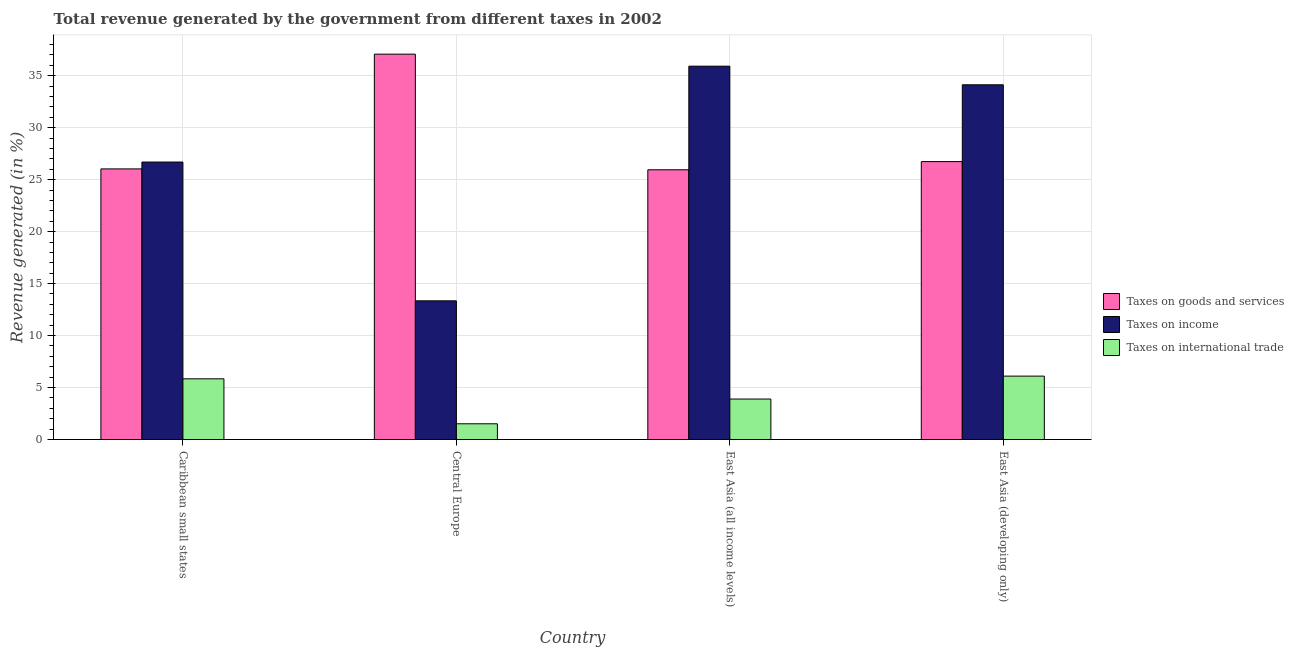How many different coloured bars are there?
Keep it short and to the point. 3. How many groups of bars are there?
Offer a terse response. 4. Are the number of bars on each tick of the X-axis equal?
Your answer should be compact. Yes. What is the label of the 2nd group of bars from the left?
Offer a very short reply. Central Europe. What is the percentage of revenue generated by tax on international trade in Central Europe?
Give a very brief answer. 1.51. Across all countries, what is the maximum percentage of revenue generated by taxes on income?
Keep it short and to the point. 35.92. Across all countries, what is the minimum percentage of revenue generated by tax on international trade?
Your answer should be compact. 1.51. In which country was the percentage of revenue generated by taxes on income maximum?
Keep it short and to the point. East Asia (all income levels). In which country was the percentage of revenue generated by taxes on goods and services minimum?
Provide a succinct answer. East Asia (all income levels). What is the total percentage of revenue generated by taxes on income in the graph?
Your answer should be very brief. 110.08. What is the difference between the percentage of revenue generated by tax on international trade in East Asia (all income levels) and that in East Asia (developing only)?
Offer a terse response. -2.2. What is the difference between the percentage of revenue generated by taxes on income in East Asia (developing only) and the percentage of revenue generated by taxes on goods and services in Caribbean small states?
Provide a short and direct response. 8.09. What is the average percentage of revenue generated by taxes on goods and services per country?
Provide a short and direct response. 28.95. What is the difference between the percentage of revenue generated by taxes on income and percentage of revenue generated by taxes on goods and services in East Asia (all income levels)?
Make the answer very short. 9.97. What is the ratio of the percentage of revenue generated by taxes on goods and services in East Asia (all income levels) to that in East Asia (developing only)?
Keep it short and to the point. 0.97. Is the difference between the percentage of revenue generated by taxes on goods and services in East Asia (all income levels) and East Asia (developing only) greater than the difference between the percentage of revenue generated by tax on international trade in East Asia (all income levels) and East Asia (developing only)?
Give a very brief answer. Yes. What is the difference between the highest and the second highest percentage of revenue generated by taxes on goods and services?
Offer a very short reply. 10.34. What is the difference between the highest and the lowest percentage of revenue generated by tax on international trade?
Give a very brief answer. 4.59. In how many countries, is the percentage of revenue generated by taxes on goods and services greater than the average percentage of revenue generated by taxes on goods and services taken over all countries?
Offer a terse response. 1. Is the sum of the percentage of revenue generated by tax on international trade in Caribbean small states and Central Europe greater than the maximum percentage of revenue generated by taxes on income across all countries?
Your response must be concise. No. What does the 1st bar from the left in Central Europe represents?
Offer a terse response. Taxes on goods and services. What does the 3rd bar from the right in Central Europe represents?
Your response must be concise. Taxes on goods and services. Are all the bars in the graph horizontal?
Keep it short and to the point. No. How many countries are there in the graph?
Give a very brief answer. 4. Does the graph contain any zero values?
Give a very brief answer. No. What is the title of the graph?
Give a very brief answer. Total revenue generated by the government from different taxes in 2002. What is the label or title of the X-axis?
Your answer should be compact. Country. What is the label or title of the Y-axis?
Make the answer very short. Revenue generated (in %). What is the Revenue generated (in %) in Taxes on goods and services in Caribbean small states?
Offer a very short reply. 26.04. What is the Revenue generated (in %) in Taxes on income in Caribbean small states?
Make the answer very short. 26.7. What is the Revenue generated (in %) of Taxes on international trade in Caribbean small states?
Provide a succinct answer. 5.84. What is the Revenue generated (in %) of Taxes on goods and services in Central Europe?
Provide a succinct answer. 37.08. What is the Revenue generated (in %) in Taxes on income in Central Europe?
Keep it short and to the point. 13.34. What is the Revenue generated (in %) in Taxes on international trade in Central Europe?
Offer a very short reply. 1.51. What is the Revenue generated (in %) in Taxes on goods and services in East Asia (all income levels)?
Offer a very short reply. 25.95. What is the Revenue generated (in %) of Taxes on income in East Asia (all income levels)?
Offer a terse response. 35.92. What is the Revenue generated (in %) in Taxes on international trade in East Asia (all income levels)?
Offer a terse response. 3.89. What is the Revenue generated (in %) in Taxes on goods and services in East Asia (developing only)?
Provide a succinct answer. 26.74. What is the Revenue generated (in %) of Taxes on income in East Asia (developing only)?
Give a very brief answer. 34.13. What is the Revenue generated (in %) of Taxes on international trade in East Asia (developing only)?
Provide a short and direct response. 6.1. Across all countries, what is the maximum Revenue generated (in %) in Taxes on goods and services?
Give a very brief answer. 37.08. Across all countries, what is the maximum Revenue generated (in %) of Taxes on income?
Keep it short and to the point. 35.92. Across all countries, what is the maximum Revenue generated (in %) of Taxes on international trade?
Provide a short and direct response. 6.1. Across all countries, what is the minimum Revenue generated (in %) in Taxes on goods and services?
Offer a very short reply. 25.95. Across all countries, what is the minimum Revenue generated (in %) of Taxes on income?
Give a very brief answer. 13.34. Across all countries, what is the minimum Revenue generated (in %) in Taxes on international trade?
Give a very brief answer. 1.51. What is the total Revenue generated (in %) of Taxes on goods and services in the graph?
Keep it short and to the point. 115.8. What is the total Revenue generated (in %) in Taxes on income in the graph?
Provide a short and direct response. 110.08. What is the total Revenue generated (in %) in Taxes on international trade in the graph?
Keep it short and to the point. 17.35. What is the difference between the Revenue generated (in %) in Taxes on goods and services in Caribbean small states and that in Central Europe?
Provide a succinct answer. -11.04. What is the difference between the Revenue generated (in %) in Taxes on income in Caribbean small states and that in Central Europe?
Your answer should be very brief. 13.35. What is the difference between the Revenue generated (in %) of Taxes on international trade in Caribbean small states and that in Central Europe?
Make the answer very short. 4.33. What is the difference between the Revenue generated (in %) of Taxes on goods and services in Caribbean small states and that in East Asia (all income levels)?
Give a very brief answer. 0.09. What is the difference between the Revenue generated (in %) of Taxes on income in Caribbean small states and that in East Asia (all income levels)?
Your answer should be very brief. -9.22. What is the difference between the Revenue generated (in %) of Taxes on international trade in Caribbean small states and that in East Asia (all income levels)?
Your answer should be very brief. 1.94. What is the difference between the Revenue generated (in %) of Taxes on goods and services in Caribbean small states and that in East Asia (developing only)?
Your answer should be compact. -0.7. What is the difference between the Revenue generated (in %) of Taxes on income in Caribbean small states and that in East Asia (developing only)?
Provide a succinct answer. -7.43. What is the difference between the Revenue generated (in %) in Taxes on international trade in Caribbean small states and that in East Asia (developing only)?
Make the answer very short. -0.26. What is the difference between the Revenue generated (in %) of Taxes on goods and services in Central Europe and that in East Asia (all income levels)?
Give a very brief answer. 11.13. What is the difference between the Revenue generated (in %) of Taxes on income in Central Europe and that in East Asia (all income levels)?
Make the answer very short. -22.58. What is the difference between the Revenue generated (in %) of Taxes on international trade in Central Europe and that in East Asia (all income levels)?
Offer a terse response. -2.38. What is the difference between the Revenue generated (in %) of Taxes on goods and services in Central Europe and that in East Asia (developing only)?
Offer a very short reply. 10.34. What is the difference between the Revenue generated (in %) in Taxes on income in Central Europe and that in East Asia (developing only)?
Make the answer very short. -20.78. What is the difference between the Revenue generated (in %) in Taxes on international trade in Central Europe and that in East Asia (developing only)?
Make the answer very short. -4.59. What is the difference between the Revenue generated (in %) of Taxes on goods and services in East Asia (all income levels) and that in East Asia (developing only)?
Your answer should be compact. -0.79. What is the difference between the Revenue generated (in %) of Taxes on income in East Asia (all income levels) and that in East Asia (developing only)?
Give a very brief answer. 1.79. What is the difference between the Revenue generated (in %) in Taxes on international trade in East Asia (all income levels) and that in East Asia (developing only)?
Make the answer very short. -2.2. What is the difference between the Revenue generated (in %) of Taxes on goods and services in Caribbean small states and the Revenue generated (in %) of Taxes on income in Central Europe?
Provide a short and direct response. 12.69. What is the difference between the Revenue generated (in %) in Taxes on goods and services in Caribbean small states and the Revenue generated (in %) in Taxes on international trade in Central Europe?
Ensure brevity in your answer.  24.52. What is the difference between the Revenue generated (in %) of Taxes on income in Caribbean small states and the Revenue generated (in %) of Taxes on international trade in Central Europe?
Keep it short and to the point. 25.18. What is the difference between the Revenue generated (in %) of Taxes on goods and services in Caribbean small states and the Revenue generated (in %) of Taxes on income in East Asia (all income levels)?
Your response must be concise. -9.88. What is the difference between the Revenue generated (in %) of Taxes on goods and services in Caribbean small states and the Revenue generated (in %) of Taxes on international trade in East Asia (all income levels)?
Give a very brief answer. 22.14. What is the difference between the Revenue generated (in %) of Taxes on income in Caribbean small states and the Revenue generated (in %) of Taxes on international trade in East Asia (all income levels)?
Provide a succinct answer. 22.8. What is the difference between the Revenue generated (in %) in Taxes on goods and services in Caribbean small states and the Revenue generated (in %) in Taxes on income in East Asia (developing only)?
Make the answer very short. -8.09. What is the difference between the Revenue generated (in %) in Taxes on goods and services in Caribbean small states and the Revenue generated (in %) in Taxes on international trade in East Asia (developing only)?
Your response must be concise. 19.94. What is the difference between the Revenue generated (in %) in Taxes on income in Caribbean small states and the Revenue generated (in %) in Taxes on international trade in East Asia (developing only)?
Make the answer very short. 20.6. What is the difference between the Revenue generated (in %) in Taxes on goods and services in Central Europe and the Revenue generated (in %) in Taxes on income in East Asia (all income levels)?
Provide a succinct answer. 1.16. What is the difference between the Revenue generated (in %) in Taxes on goods and services in Central Europe and the Revenue generated (in %) in Taxes on international trade in East Asia (all income levels)?
Make the answer very short. 33.18. What is the difference between the Revenue generated (in %) in Taxes on income in Central Europe and the Revenue generated (in %) in Taxes on international trade in East Asia (all income levels)?
Make the answer very short. 9.45. What is the difference between the Revenue generated (in %) in Taxes on goods and services in Central Europe and the Revenue generated (in %) in Taxes on income in East Asia (developing only)?
Offer a terse response. 2.95. What is the difference between the Revenue generated (in %) in Taxes on goods and services in Central Europe and the Revenue generated (in %) in Taxes on international trade in East Asia (developing only)?
Give a very brief answer. 30.98. What is the difference between the Revenue generated (in %) of Taxes on income in Central Europe and the Revenue generated (in %) of Taxes on international trade in East Asia (developing only)?
Your answer should be very brief. 7.24. What is the difference between the Revenue generated (in %) of Taxes on goods and services in East Asia (all income levels) and the Revenue generated (in %) of Taxes on income in East Asia (developing only)?
Give a very brief answer. -8.18. What is the difference between the Revenue generated (in %) in Taxes on goods and services in East Asia (all income levels) and the Revenue generated (in %) in Taxes on international trade in East Asia (developing only)?
Make the answer very short. 19.85. What is the difference between the Revenue generated (in %) of Taxes on income in East Asia (all income levels) and the Revenue generated (in %) of Taxes on international trade in East Asia (developing only)?
Your answer should be compact. 29.82. What is the average Revenue generated (in %) in Taxes on goods and services per country?
Offer a terse response. 28.95. What is the average Revenue generated (in %) in Taxes on income per country?
Offer a terse response. 27.52. What is the average Revenue generated (in %) in Taxes on international trade per country?
Offer a very short reply. 4.34. What is the difference between the Revenue generated (in %) in Taxes on goods and services and Revenue generated (in %) in Taxes on income in Caribbean small states?
Provide a short and direct response. -0.66. What is the difference between the Revenue generated (in %) of Taxes on goods and services and Revenue generated (in %) of Taxes on international trade in Caribbean small states?
Your answer should be very brief. 20.2. What is the difference between the Revenue generated (in %) of Taxes on income and Revenue generated (in %) of Taxes on international trade in Caribbean small states?
Your answer should be compact. 20.86. What is the difference between the Revenue generated (in %) in Taxes on goods and services and Revenue generated (in %) in Taxes on income in Central Europe?
Provide a succinct answer. 23.73. What is the difference between the Revenue generated (in %) in Taxes on goods and services and Revenue generated (in %) in Taxes on international trade in Central Europe?
Offer a terse response. 35.56. What is the difference between the Revenue generated (in %) in Taxes on income and Revenue generated (in %) in Taxes on international trade in Central Europe?
Provide a short and direct response. 11.83. What is the difference between the Revenue generated (in %) in Taxes on goods and services and Revenue generated (in %) in Taxes on income in East Asia (all income levels)?
Provide a short and direct response. -9.97. What is the difference between the Revenue generated (in %) in Taxes on goods and services and Revenue generated (in %) in Taxes on international trade in East Asia (all income levels)?
Your answer should be very brief. 22.05. What is the difference between the Revenue generated (in %) in Taxes on income and Revenue generated (in %) in Taxes on international trade in East Asia (all income levels)?
Offer a very short reply. 32.02. What is the difference between the Revenue generated (in %) in Taxes on goods and services and Revenue generated (in %) in Taxes on income in East Asia (developing only)?
Your response must be concise. -7.39. What is the difference between the Revenue generated (in %) in Taxes on goods and services and Revenue generated (in %) in Taxes on international trade in East Asia (developing only)?
Make the answer very short. 20.64. What is the difference between the Revenue generated (in %) of Taxes on income and Revenue generated (in %) of Taxes on international trade in East Asia (developing only)?
Make the answer very short. 28.03. What is the ratio of the Revenue generated (in %) in Taxes on goods and services in Caribbean small states to that in Central Europe?
Provide a short and direct response. 0.7. What is the ratio of the Revenue generated (in %) of Taxes on income in Caribbean small states to that in Central Europe?
Offer a very short reply. 2. What is the ratio of the Revenue generated (in %) of Taxes on international trade in Caribbean small states to that in Central Europe?
Make the answer very short. 3.86. What is the ratio of the Revenue generated (in %) of Taxes on income in Caribbean small states to that in East Asia (all income levels)?
Your answer should be very brief. 0.74. What is the ratio of the Revenue generated (in %) in Taxes on international trade in Caribbean small states to that in East Asia (all income levels)?
Make the answer very short. 1.5. What is the ratio of the Revenue generated (in %) of Taxes on goods and services in Caribbean small states to that in East Asia (developing only)?
Make the answer very short. 0.97. What is the ratio of the Revenue generated (in %) in Taxes on income in Caribbean small states to that in East Asia (developing only)?
Give a very brief answer. 0.78. What is the ratio of the Revenue generated (in %) of Taxes on international trade in Caribbean small states to that in East Asia (developing only)?
Give a very brief answer. 0.96. What is the ratio of the Revenue generated (in %) in Taxes on goods and services in Central Europe to that in East Asia (all income levels)?
Keep it short and to the point. 1.43. What is the ratio of the Revenue generated (in %) in Taxes on income in Central Europe to that in East Asia (all income levels)?
Provide a short and direct response. 0.37. What is the ratio of the Revenue generated (in %) of Taxes on international trade in Central Europe to that in East Asia (all income levels)?
Give a very brief answer. 0.39. What is the ratio of the Revenue generated (in %) of Taxes on goods and services in Central Europe to that in East Asia (developing only)?
Offer a very short reply. 1.39. What is the ratio of the Revenue generated (in %) in Taxes on income in Central Europe to that in East Asia (developing only)?
Your answer should be very brief. 0.39. What is the ratio of the Revenue generated (in %) in Taxes on international trade in Central Europe to that in East Asia (developing only)?
Keep it short and to the point. 0.25. What is the ratio of the Revenue generated (in %) in Taxes on goods and services in East Asia (all income levels) to that in East Asia (developing only)?
Your answer should be very brief. 0.97. What is the ratio of the Revenue generated (in %) in Taxes on income in East Asia (all income levels) to that in East Asia (developing only)?
Provide a short and direct response. 1.05. What is the ratio of the Revenue generated (in %) in Taxes on international trade in East Asia (all income levels) to that in East Asia (developing only)?
Make the answer very short. 0.64. What is the difference between the highest and the second highest Revenue generated (in %) of Taxes on goods and services?
Keep it short and to the point. 10.34. What is the difference between the highest and the second highest Revenue generated (in %) in Taxes on income?
Offer a very short reply. 1.79. What is the difference between the highest and the second highest Revenue generated (in %) of Taxes on international trade?
Offer a very short reply. 0.26. What is the difference between the highest and the lowest Revenue generated (in %) in Taxes on goods and services?
Offer a terse response. 11.13. What is the difference between the highest and the lowest Revenue generated (in %) in Taxes on income?
Ensure brevity in your answer.  22.58. What is the difference between the highest and the lowest Revenue generated (in %) of Taxes on international trade?
Offer a terse response. 4.59. 